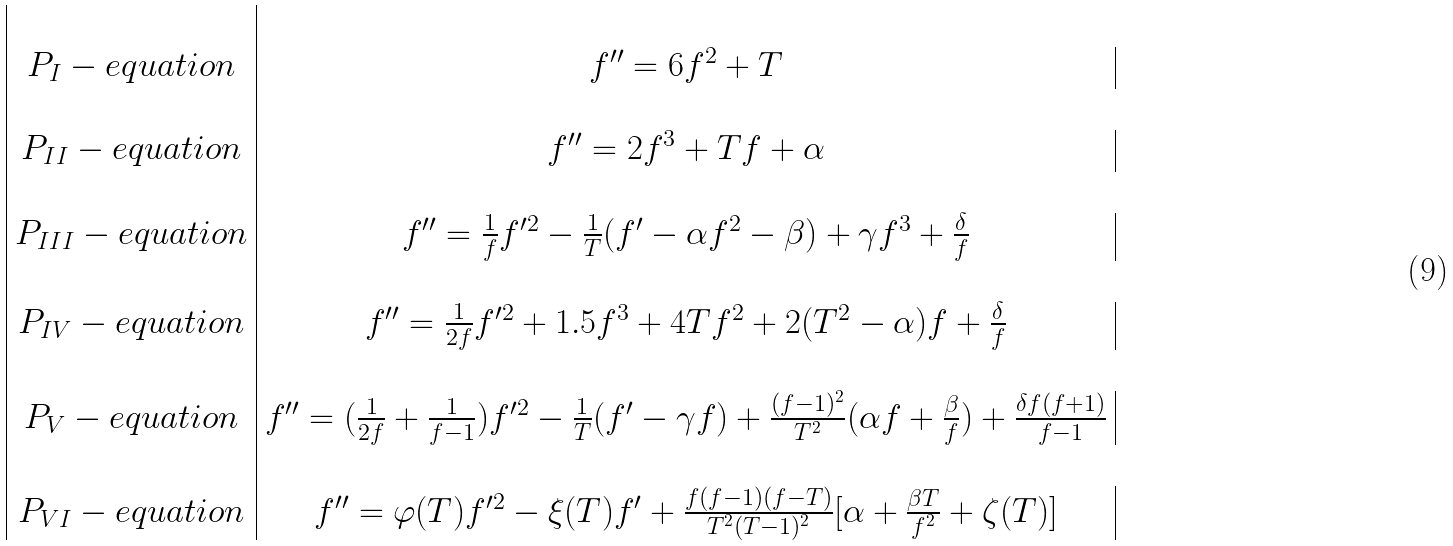<formula> <loc_0><loc_0><loc_500><loc_500>\begin{array} { | c | c | } \\ P _ { I } - e q u a t i o n & f ^ { \prime \prime } = 6 f ^ { 2 } + T \\ \\ P _ { I I } - e q u a t i o n & f ^ { \prime \prime } = 2 f ^ { 3 } + T f + \alpha \\ \\ P _ { I I I } - e q u a t i o n & f ^ { \prime \prime } = \frac { 1 } { f } f ^ { \prime 2 } - \frac { 1 } { T } ( f ^ { \prime } - \alpha f ^ { 2 } - \beta ) + \gamma f ^ { 3 } + \frac { \delta } { f } \\ \\ P _ { I V } - e q u a t i o n & f ^ { \prime \prime } = \frac { 1 } { 2 f } f ^ { \prime 2 } + 1 . 5 f ^ { 3 } + 4 T f ^ { 2 } + 2 ( T ^ { 2 } - \alpha ) f + \frac { \delta } { f } \\ \\ P _ { V } - e q u a t i o n & f ^ { \prime \prime } = ( \frac { 1 } { 2 f } + \frac { 1 } { f - 1 } ) f ^ { \prime 2 } - \frac { 1 } { T } ( f ^ { \prime } - \gamma f ) + \frac { ( f - 1 ) ^ { 2 } } { T ^ { 2 } } ( \alpha f + \frac { \beta } { f } ) + \frac { \delta f ( f + 1 ) } { f - 1 } \\ \\ P _ { V I } - e q u a t i o n & f ^ { \prime \prime } = \varphi ( T ) f ^ { \prime 2 } - \xi ( T ) f ^ { \prime } + \frac { f ( f - 1 ) ( f - T ) } { T ^ { 2 } ( T - 1 ) ^ { 2 } } [ \alpha + \frac { \beta T } { f ^ { 2 } } + \zeta ( T ) ] \\ \end{array}</formula> 